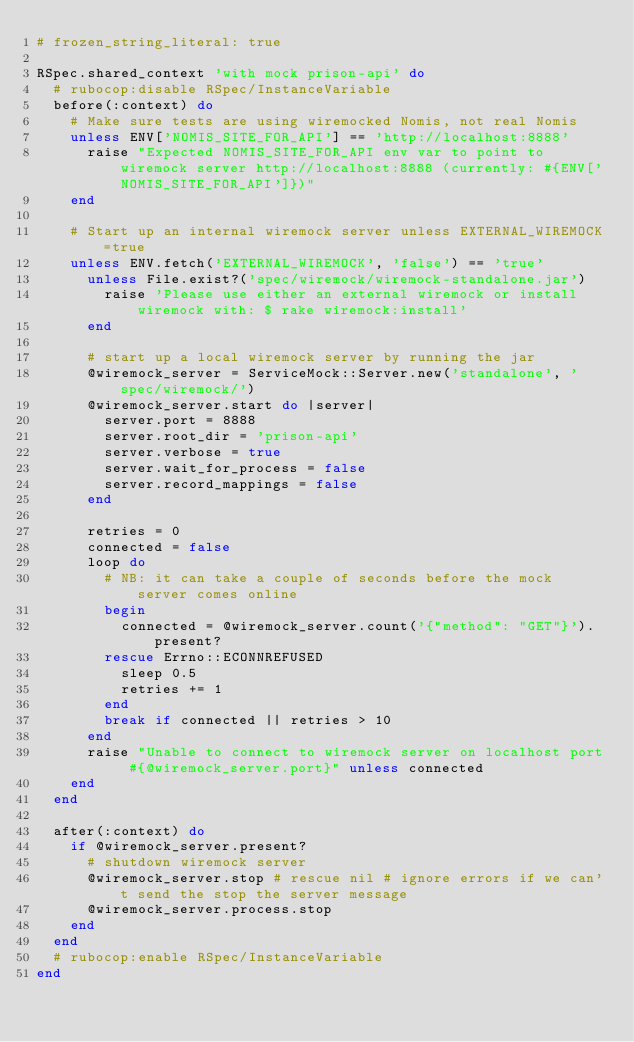Convert code to text. <code><loc_0><loc_0><loc_500><loc_500><_Ruby_># frozen_string_literal: true

RSpec.shared_context 'with mock prison-api' do
  # rubocop:disable RSpec/InstanceVariable
  before(:context) do
    # Make sure tests are using wiremocked Nomis, not real Nomis
    unless ENV['NOMIS_SITE_FOR_API'] == 'http://localhost:8888'
      raise "Expected NOMIS_SITE_FOR_API env var to point to wiremock server http://localhost:8888 (currently: #{ENV['NOMIS_SITE_FOR_API']})"
    end

    # Start up an internal wiremock server unless EXTERNAL_WIREMOCK=true
    unless ENV.fetch('EXTERNAL_WIREMOCK', 'false') == 'true'
      unless File.exist?('spec/wiremock/wiremock-standalone.jar')
        raise 'Please use either an external wiremock or install wiremock with: $ rake wiremock:install'
      end

      # start up a local wiremock server by running the jar
      @wiremock_server = ServiceMock::Server.new('standalone', 'spec/wiremock/')
      @wiremock_server.start do |server|
        server.port = 8888
        server.root_dir = 'prison-api'
        server.verbose = true
        server.wait_for_process = false
        server.record_mappings = false
      end

      retries = 0
      connected = false
      loop do
        # NB: it can take a couple of seconds before the mock server comes online
        begin
          connected = @wiremock_server.count('{"method": "GET"}').present?
        rescue Errno::ECONNREFUSED
          sleep 0.5
          retries += 1
        end
        break if connected || retries > 10
      end
      raise "Unable to connect to wiremock server on localhost port #{@wiremock_server.port}" unless connected
    end
  end

  after(:context) do
    if @wiremock_server.present?
      # shutdown wiremock server
      @wiremock_server.stop # rescue nil # ignore errors if we can't send the stop the server message
      @wiremock_server.process.stop
    end
  end
  # rubocop:enable RSpec/InstanceVariable
end
</code> 